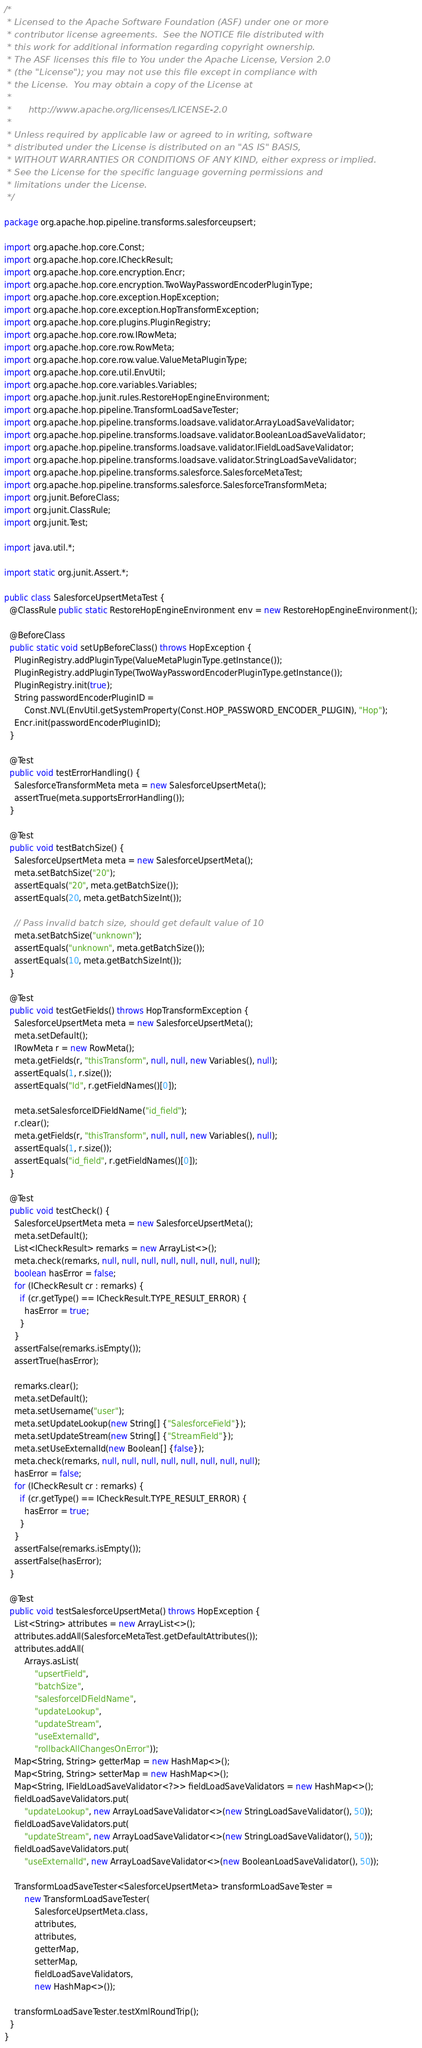Convert code to text. <code><loc_0><loc_0><loc_500><loc_500><_Java_>/*
 * Licensed to the Apache Software Foundation (ASF) under one or more
 * contributor license agreements.  See the NOTICE file distributed with
 * this work for additional information regarding copyright ownership.
 * The ASF licenses this file to You under the Apache License, Version 2.0
 * (the "License"); you may not use this file except in compliance with
 * the License.  You may obtain a copy of the License at
 *
 *      http://www.apache.org/licenses/LICENSE-2.0
 *
 * Unless required by applicable law or agreed to in writing, software
 * distributed under the License is distributed on an "AS IS" BASIS,
 * WITHOUT WARRANTIES OR CONDITIONS OF ANY KIND, either express or implied.
 * See the License for the specific language governing permissions and
 * limitations under the License.
 */

package org.apache.hop.pipeline.transforms.salesforceupsert;

import org.apache.hop.core.Const;
import org.apache.hop.core.ICheckResult;
import org.apache.hop.core.encryption.Encr;
import org.apache.hop.core.encryption.TwoWayPasswordEncoderPluginType;
import org.apache.hop.core.exception.HopException;
import org.apache.hop.core.exception.HopTransformException;
import org.apache.hop.core.plugins.PluginRegistry;
import org.apache.hop.core.row.IRowMeta;
import org.apache.hop.core.row.RowMeta;
import org.apache.hop.core.row.value.ValueMetaPluginType;
import org.apache.hop.core.util.EnvUtil;
import org.apache.hop.core.variables.Variables;
import org.apache.hop.junit.rules.RestoreHopEngineEnvironment;
import org.apache.hop.pipeline.TransformLoadSaveTester;
import org.apache.hop.pipeline.transforms.loadsave.validator.ArrayLoadSaveValidator;
import org.apache.hop.pipeline.transforms.loadsave.validator.BooleanLoadSaveValidator;
import org.apache.hop.pipeline.transforms.loadsave.validator.IFieldLoadSaveValidator;
import org.apache.hop.pipeline.transforms.loadsave.validator.StringLoadSaveValidator;
import org.apache.hop.pipeline.transforms.salesforce.SalesforceMetaTest;
import org.apache.hop.pipeline.transforms.salesforce.SalesforceTransformMeta;
import org.junit.BeforeClass;
import org.junit.ClassRule;
import org.junit.Test;

import java.util.*;

import static org.junit.Assert.*;

public class SalesforceUpsertMetaTest {
  @ClassRule public static RestoreHopEngineEnvironment env = new RestoreHopEngineEnvironment();

  @BeforeClass
  public static void setUpBeforeClass() throws HopException {
    PluginRegistry.addPluginType(ValueMetaPluginType.getInstance());
    PluginRegistry.addPluginType(TwoWayPasswordEncoderPluginType.getInstance());
    PluginRegistry.init(true);
    String passwordEncoderPluginID =
        Const.NVL(EnvUtil.getSystemProperty(Const.HOP_PASSWORD_ENCODER_PLUGIN), "Hop");
    Encr.init(passwordEncoderPluginID);
  }

  @Test
  public void testErrorHandling() {
    SalesforceTransformMeta meta = new SalesforceUpsertMeta();
    assertTrue(meta.supportsErrorHandling());
  }

  @Test
  public void testBatchSize() {
    SalesforceUpsertMeta meta = new SalesforceUpsertMeta();
    meta.setBatchSize("20");
    assertEquals("20", meta.getBatchSize());
    assertEquals(20, meta.getBatchSizeInt());

    // Pass invalid batch size, should get default value of 10
    meta.setBatchSize("unknown");
    assertEquals("unknown", meta.getBatchSize());
    assertEquals(10, meta.getBatchSizeInt());
  }

  @Test
  public void testGetFields() throws HopTransformException {
    SalesforceUpsertMeta meta = new SalesforceUpsertMeta();
    meta.setDefault();
    IRowMeta r = new RowMeta();
    meta.getFields(r, "thisTransform", null, null, new Variables(), null);
    assertEquals(1, r.size());
    assertEquals("Id", r.getFieldNames()[0]);

    meta.setSalesforceIDFieldName("id_field");
    r.clear();
    meta.getFields(r, "thisTransform", null, null, new Variables(), null);
    assertEquals(1, r.size());
    assertEquals("id_field", r.getFieldNames()[0]);
  }

  @Test
  public void testCheck() {
    SalesforceUpsertMeta meta = new SalesforceUpsertMeta();
    meta.setDefault();
    List<ICheckResult> remarks = new ArrayList<>();
    meta.check(remarks, null, null, null, null, null, null, null, null);
    boolean hasError = false;
    for (ICheckResult cr : remarks) {
      if (cr.getType() == ICheckResult.TYPE_RESULT_ERROR) {
        hasError = true;
      }
    }
    assertFalse(remarks.isEmpty());
    assertTrue(hasError);

    remarks.clear();
    meta.setDefault();
    meta.setUsername("user");
    meta.setUpdateLookup(new String[] {"SalesforceField"});
    meta.setUpdateStream(new String[] {"StreamField"});
    meta.setUseExternalId(new Boolean[] {false});
    meta.check(remarks, null, null, null, null, null, null, null, null);
    hasError = false;
    for (ICheckResult cr : remarks) {
      if (cr.getType() == ICheckResult.TYPE_RESULT_ERROR) {
        hasError = true;
      }
    }
    assertFalse(remarks.isEmpty());
    assertFalse(hasError);
  }

  @Test
  public void testSalesforceUpsertMeta() throws HopException {
    List<String> attributes = new ArrayList<>();
    attributes.addAll(SalesforceMetaTest.getDefaultAttributes());
    attributes.addAll(
        Arrays.asList(
            "upsertField",
            "batchSize",
            "salesforceIDFieldName",
            "updateLookup",
            "updateStream",
            "useExternalId",
            "rollbackAllChangesOnError"));
    Map<String, String> getterMap = new HashMap<>();
    Map<String, String> setterMap = new HashMap<>();
    Map<String, IFieldLoadSaveValidator<?>> fieldLoadSaveValidators = new HashMap<>();
    fieldLoadSaveValidators.put(
        "updateLookup", new ArrayLoadSaveValidator<>(new StringLoadSaveValidator(), 50));
    fieldLoadSaveValidators.put(
        "updateStream", new ArrayLoadSaveValidator<>(new StringLoadSaveValidator(), 50));
    fieldLoadSaveValidators.put(
        "useExternalId", new ArrayLoadSaveValidator<>(new BooleanLoadSaveValidator(), 50));

    TransformLoadSaveTester<SalesforceUpsertMeta> transformLoadSaveTester =
        new TransformLoadSaveTester(
            SalesforceUpsertMeta.class,
            attributes,
            attributes,
            getterMap,
            setterMap,
            fieldLoadSaveValidators,
            new HashMap<>());

    transformLoadSaveTester.testXmlRoundTrip();
  }
}
</code> 